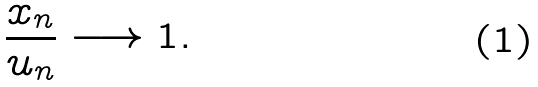<formula> <loc_0><loc_0><loc_500><loc_500>\frac { x _ { n } } { u _ { n } } \longrightarrow 1 .</formula> 